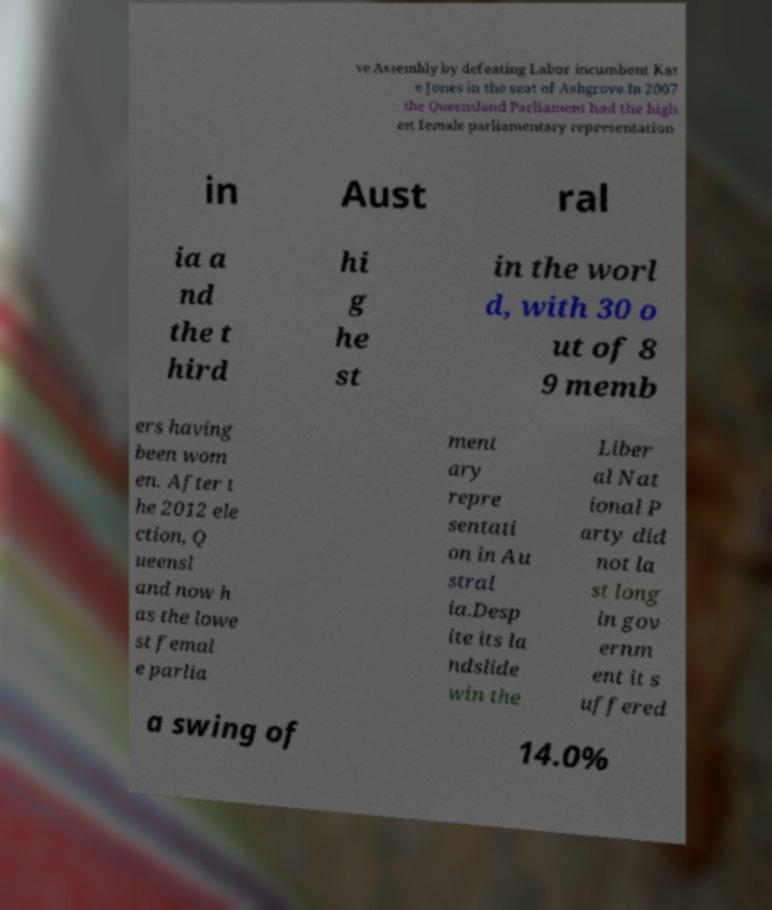There's text embedded in this image that I need extracted. Can you transcribe it verbatim? ve Assembly by defeating Labor incumbent Kat e Jones in the seat of Ashgrove.In 2007 the Queensland Parliament had the high est female parliamentary representation in Aust ral ia a nd the t hird hi g he st in the worl d, with 30 o ut of 8 9 memb ers having been wom en. After t he 2012 ele ction, Q ueensl and now h as the lowe st femal e parlia ment ary repre sentati on in Au stral ia.Desp ite its la ndslide win the Liber al Nat ional P arty did not la st long in gov ernm ent it s uffered a swing of 14.0% 